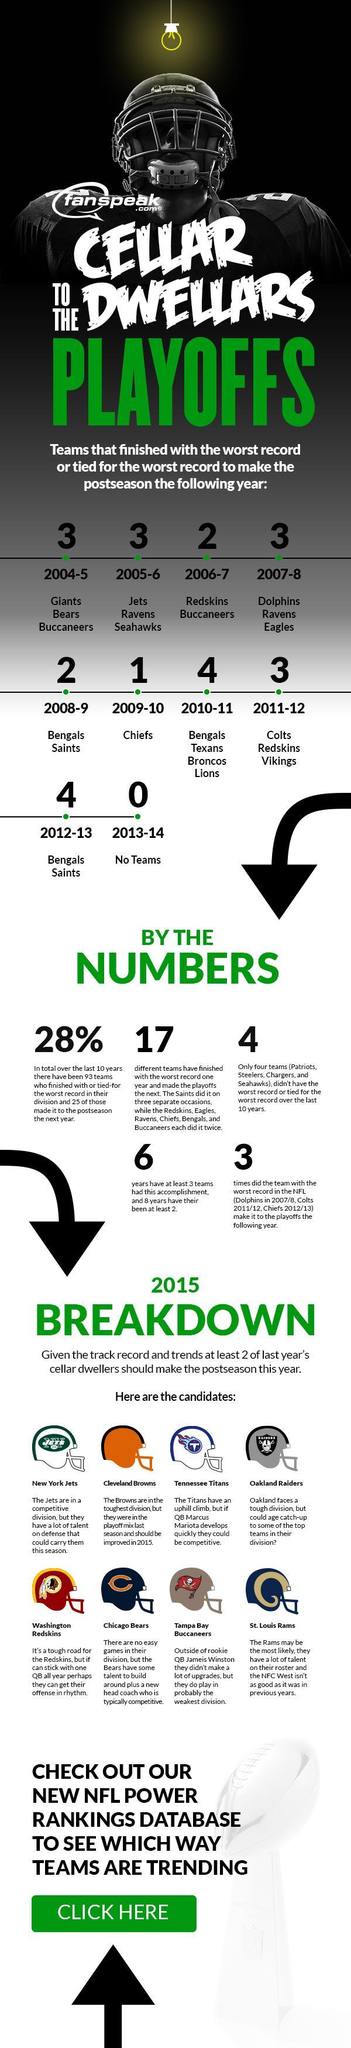WHich were the years when there were 2 teams that finished with the worst record, or tied for the worst record
Answer the question with a short phrase. 2006-7, 2008-9 How many different teams have finished with the worst record one year 17 Which seasons have saints had the worst record 2008-9, 2012-13 Which years did the teams with the worst record in the NFL make it to the playoffs the following year 2007/8, 2011/12, 2012/13 what is the colour of the helmet of washington redskins, red or blue red Which are the teams that finished with the worst record or tied for the worst records in 2005-6 Jets, Ravens, Seahawks 